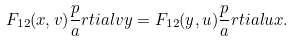Convert formula to latex. <formula><loc_0><loc_0><loc_500><loc_500>F _ { 1 2 } ( x , v ) \frac { p } { a } r t i a l { v } { y } = F _ { 1 2 } ( y , u ) \frac { p } { a } r t i a l { u } { x } .</formula> 